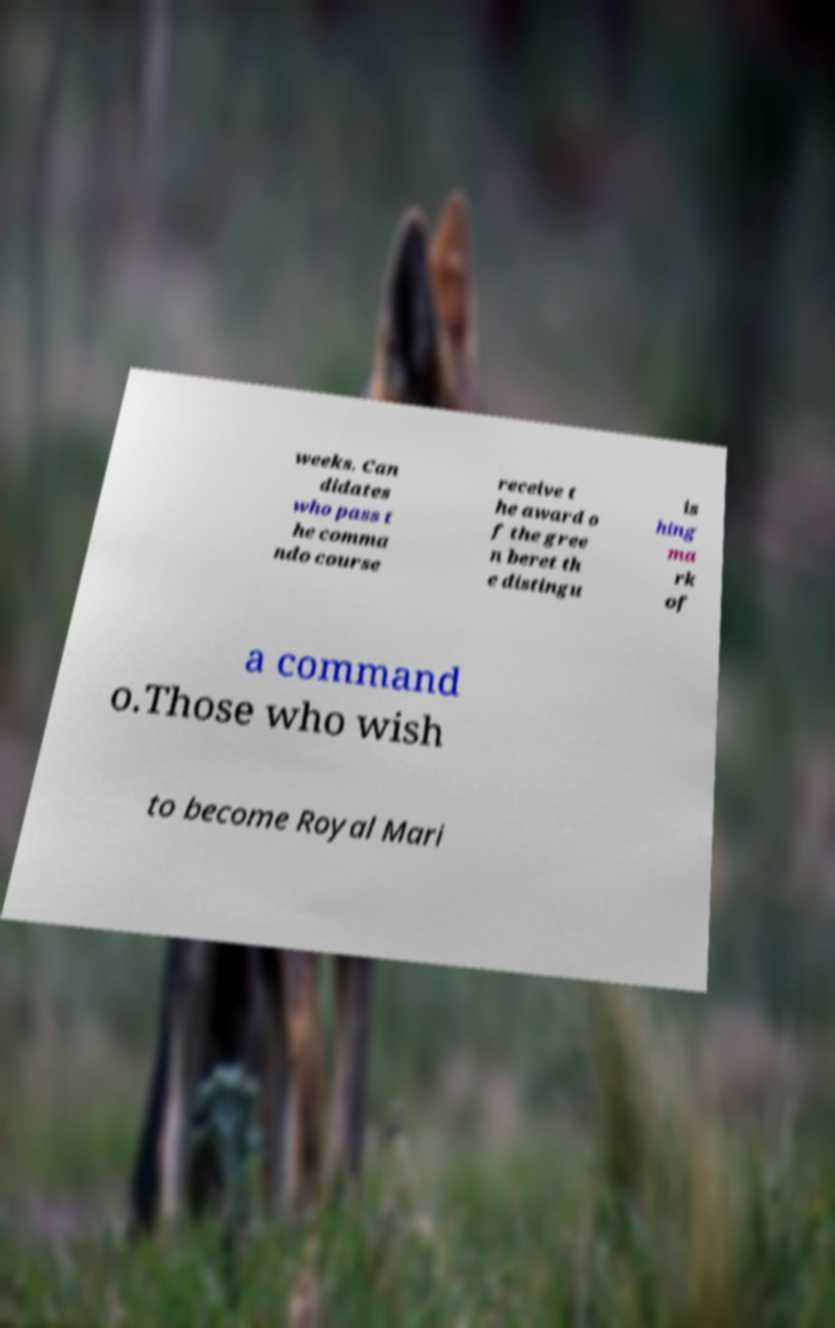Can you accurately transcribe the text from the provided image for me? weeks. Can didates who pass t he comma ndo course receive t he award o f the gree n beret th e distingu is hing ma rk of a command o.Those who wish to become Royal Mari 